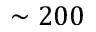Convert formula to latex. <formula><loc_0><loc_0><loc_500><loc_500>\sim 2 0 0</formula> 